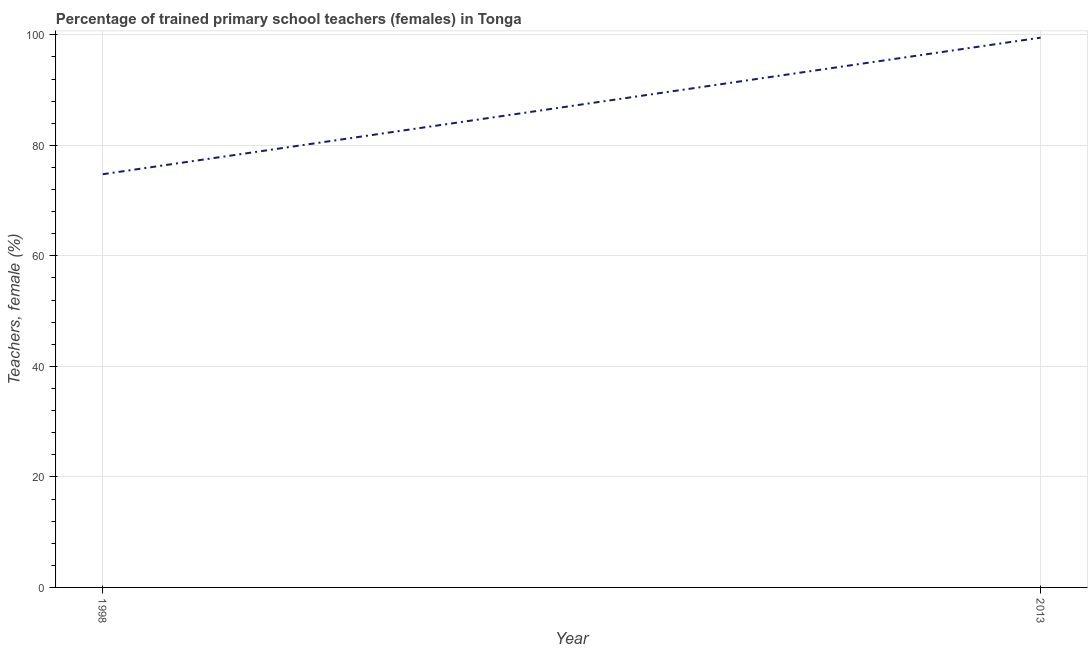What is the percentage of trained female teachers in 2013?
Provide a short and direct response. 99.49. Across all years, what is the maximum percentage of trained female teachers?
Provide a short and direct response. 99.49. Across all years, what is the minimum percentage of trained female teachers?
Ensure brevity in your answer.  74.78. What is the sum of the percentage of trained female teachers?
Ensure brevity in your answer.  174.27. What is the difference between the percentage of trained female teachers in 1998 and 2013?
Your answer should be compact. -24.72. What is the average percentage of trained female teachers per year?
Offer a terse response. 87.14. What is the median percentage of trained female teachers?
Your response must be concise. 87.14. In how many years, is the percentage of trained female teachers greater than 84 %?
Your answer should be very brief. 1. What is the ratio of the percentage of trained female teachers in 1998 to that in 2013?
Provide a succinct answer. 0.75. What is the difference between two consecutive major ticks on the Y-axis?
Keep it short and to the point. 20. Does the graph contain any zero values?
Make the answer very short. No. Does the graph contain grids?
Make the answer very short. Yes. What is the title of the graph?
Keep it short and to the point. Percentage of trained primary school teachers (females) in Tonga. What is the label or title of the Y-axis?
Provide a short and direct response. Teachers, female (%). What is the Teachers, female (%) of 1998?
Provide a short and direct response. 74.78. What is the Teachers, female (%) of 2013?
Ensure brevity in your answer.  99.49. What is the difference between the Teachers, female (%) in 1998 and 2013?
Your answer should be very brief. -24.72. What is the ratio of the Teachers, female (%) in 1998 to that in 2013?
Provide a succinct answer. 0.75. 